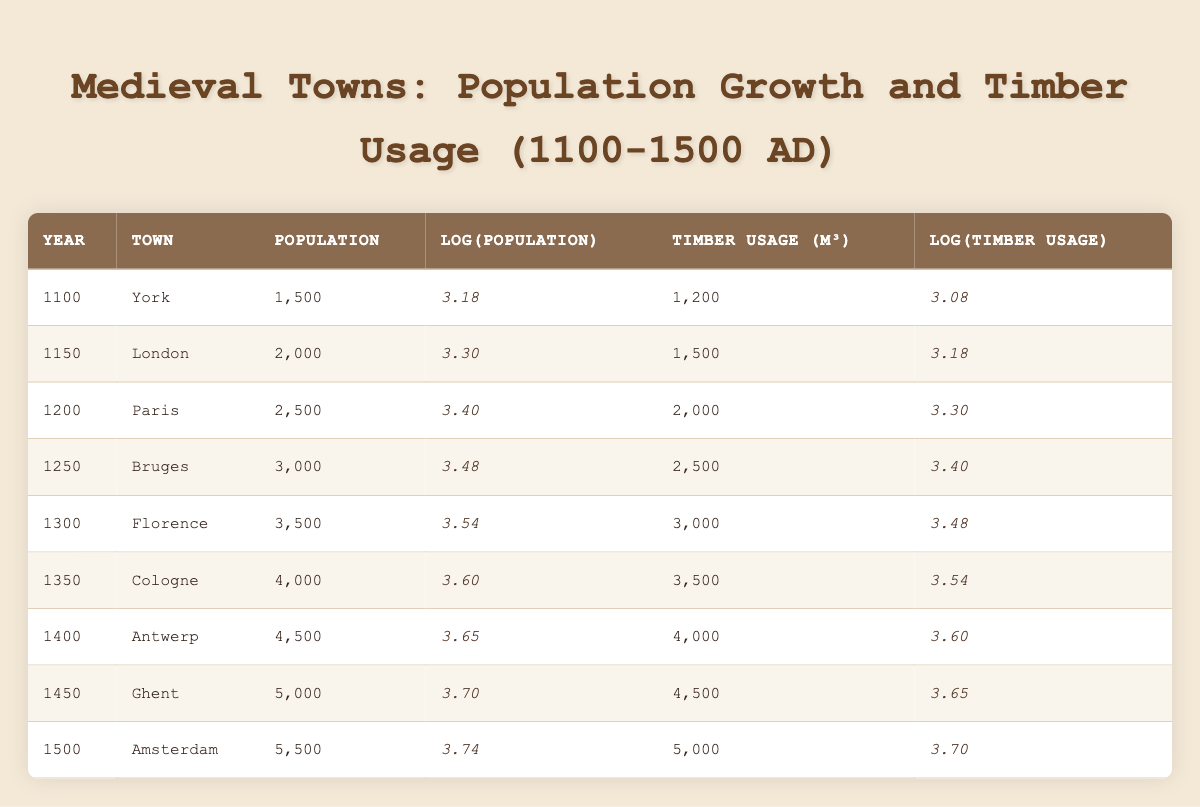What was the population of Bruges in 1250? The table lists Bruges' population for the year 1250 as 3,000. This is directly found under the "Population" column for the specified year and town.
Answer: 3000 What is the timber usage in m³ for Antwerp in 1400? According to the table, Antwerp's timber usage in 1400 is listed as 4,000 m³, found under the "Timber Usage (m³)" column for that year and town.
Answer: 4000 What year had the highest population growth and what was that growth? By examining the population values for each town over the years, the population grew from 5,000 (Ghent) in 1450 to 5,500 (Amsterdam) in 1500, resulting in a growth of 500. This is the highest growth recorded between two consecutive years.
Answer: 500 Was the log value of timber usage higher in Paris or London? In the table, the log value of timber usage for Paris is 3.30 and for London is 3.18. Since 3.30 is greater than 3.18, the log value for timber usage in Paris is higher.
Answer: Yes What is the ratio of the population in 1400 (Antwerp) to the population in 1100 (York)? The population in 1400 for Antwerp is 4,500 and in 1100 for York it is 1,500. To find the ratio, divide 4,500 by 1,500, which equals 3. This indicates that the population in Antwerp was three times that of York in their respective years.
Answer: 3 What was the average log population value from 1100 to 1500? The log population values for the years 1100 to 1500 are 3.18, 3.30, 3.40, 3.48, 3.54, 3.60, 3.65, 3.70, and 3.74. Summing these gives 30.19, and there are 9 entries, so dividing the total by 9 results in an average log population value of approximately 3.35.
Answer: 3.35 In which year did Cologne have a higher timber usage than Bruges? The timber usage for Cologne in 1350 is 3,500 m³, while Bruges in 1250 had timber usage of 2,500 m³. Therefore, Cologne's usage was higher in 1350 compared to Bruges' usage in 1250.
Answer: Yes How much did the timber usage in m³ increase from 1300 (Florence) to 1500 (Amsterdam)? The timber usage for Florence in 1300 is 3,000 m³ and for Amsterdam in 1500 is 5,000 m³. To find the increase, subtract 3,000 from 5,000, which results in an increase of 2,000 m³.
Answer: 2000 